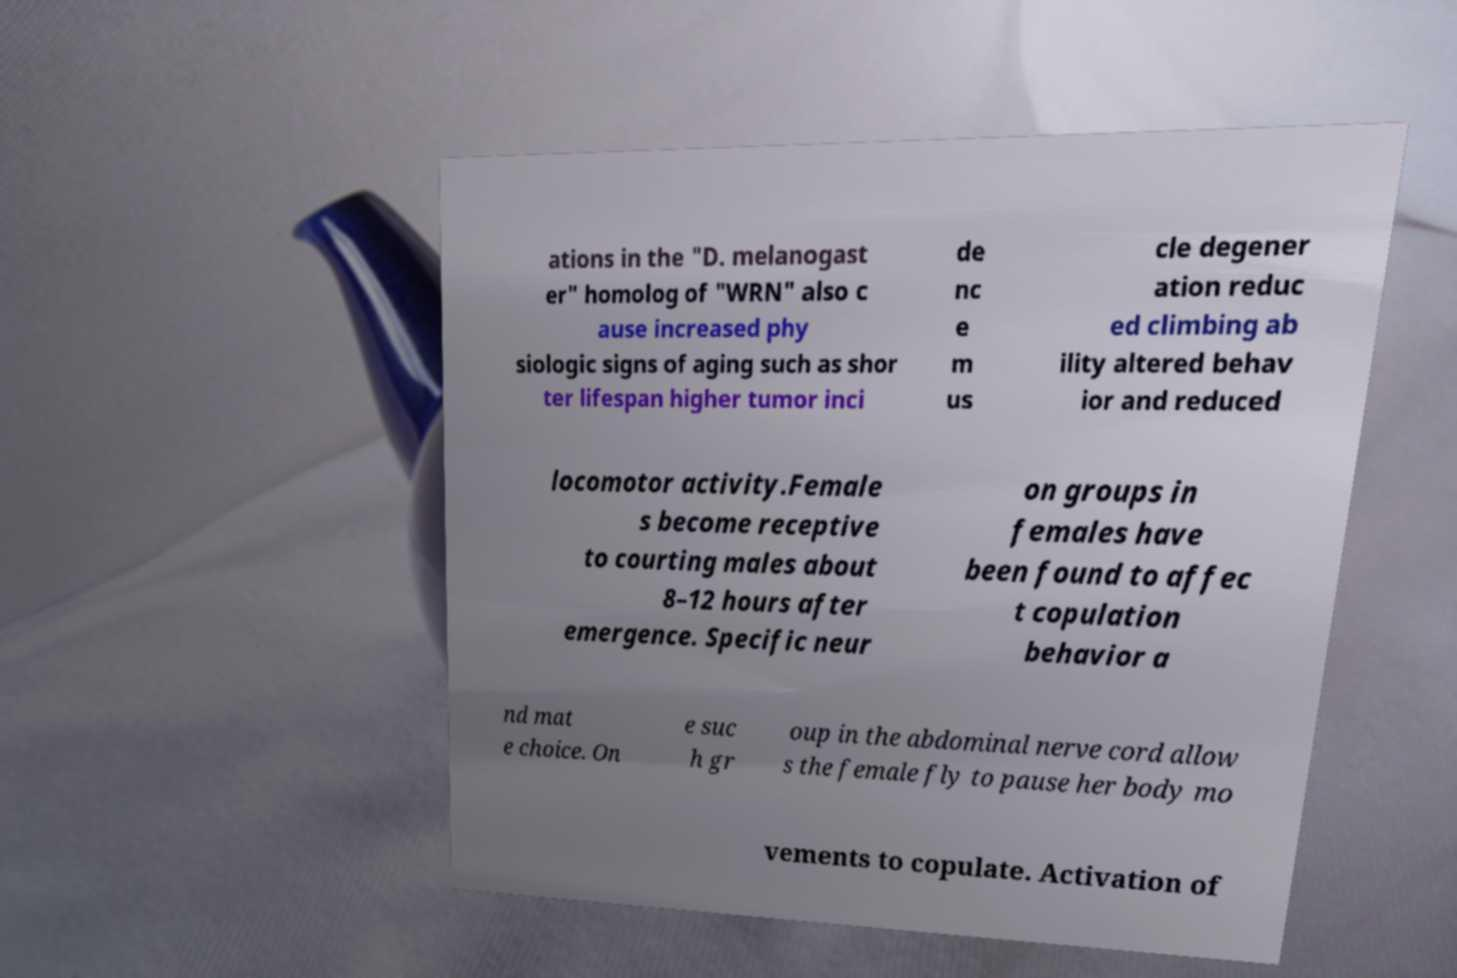I need the written content from this picture converted into text. Can you do that? ations in the "D. melanogast er" homolog of "WRN" also c ause increased phy siologic signs of aging such as shor ter lifespan higher tumor inci de nc e m us cle degener ation reduc ed climbing ab ility altered behav ior and reduced locomotor activity.Female s become receptive to courting males about 8–12 hours after emergence. Specific neur on groups in females have been found to affec t copulation behavior a nd mat e choice. On e suc h gr oup in the abdominal nerve cord allow s the female fly to pause her body mo vements to copulate. Activation of 